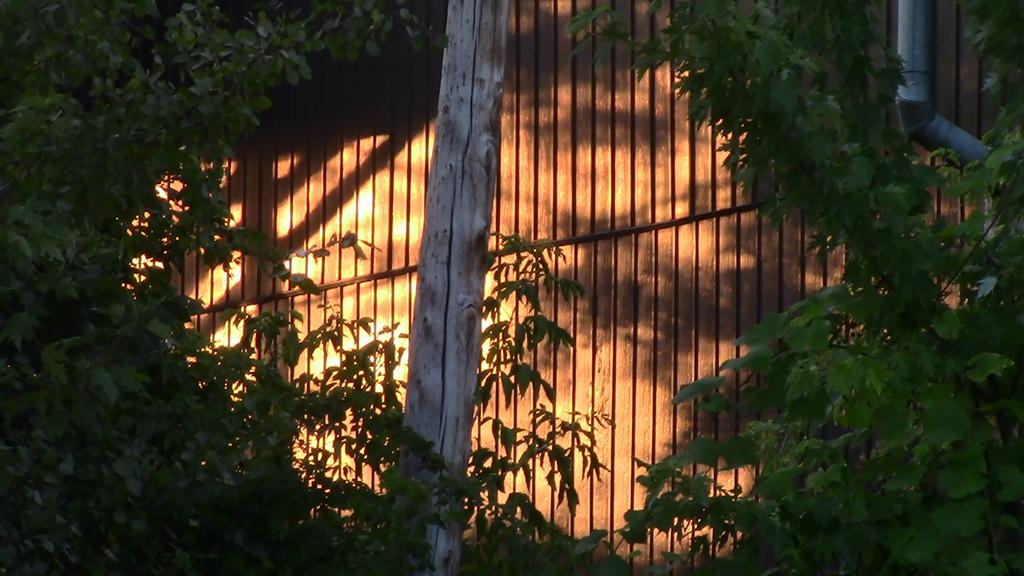What type of living organisms can be seen in the image? Plants can be seen in the image. What material is the wall in the image made of? The wall in the image is made of wood. What is located in front of the wooden wall? There is a pole in front of the wooden wall. Where is the pipe located in the image? The pipe is in the top right of the image. What type of noise can be heard coming from the pipe in the image? There is no indication of noise in the image, as it is a static representation. Can you describe the spark emitted by the plants in the image? There is no spark emitted by the plants in the image, as plants do not produce sparks. 